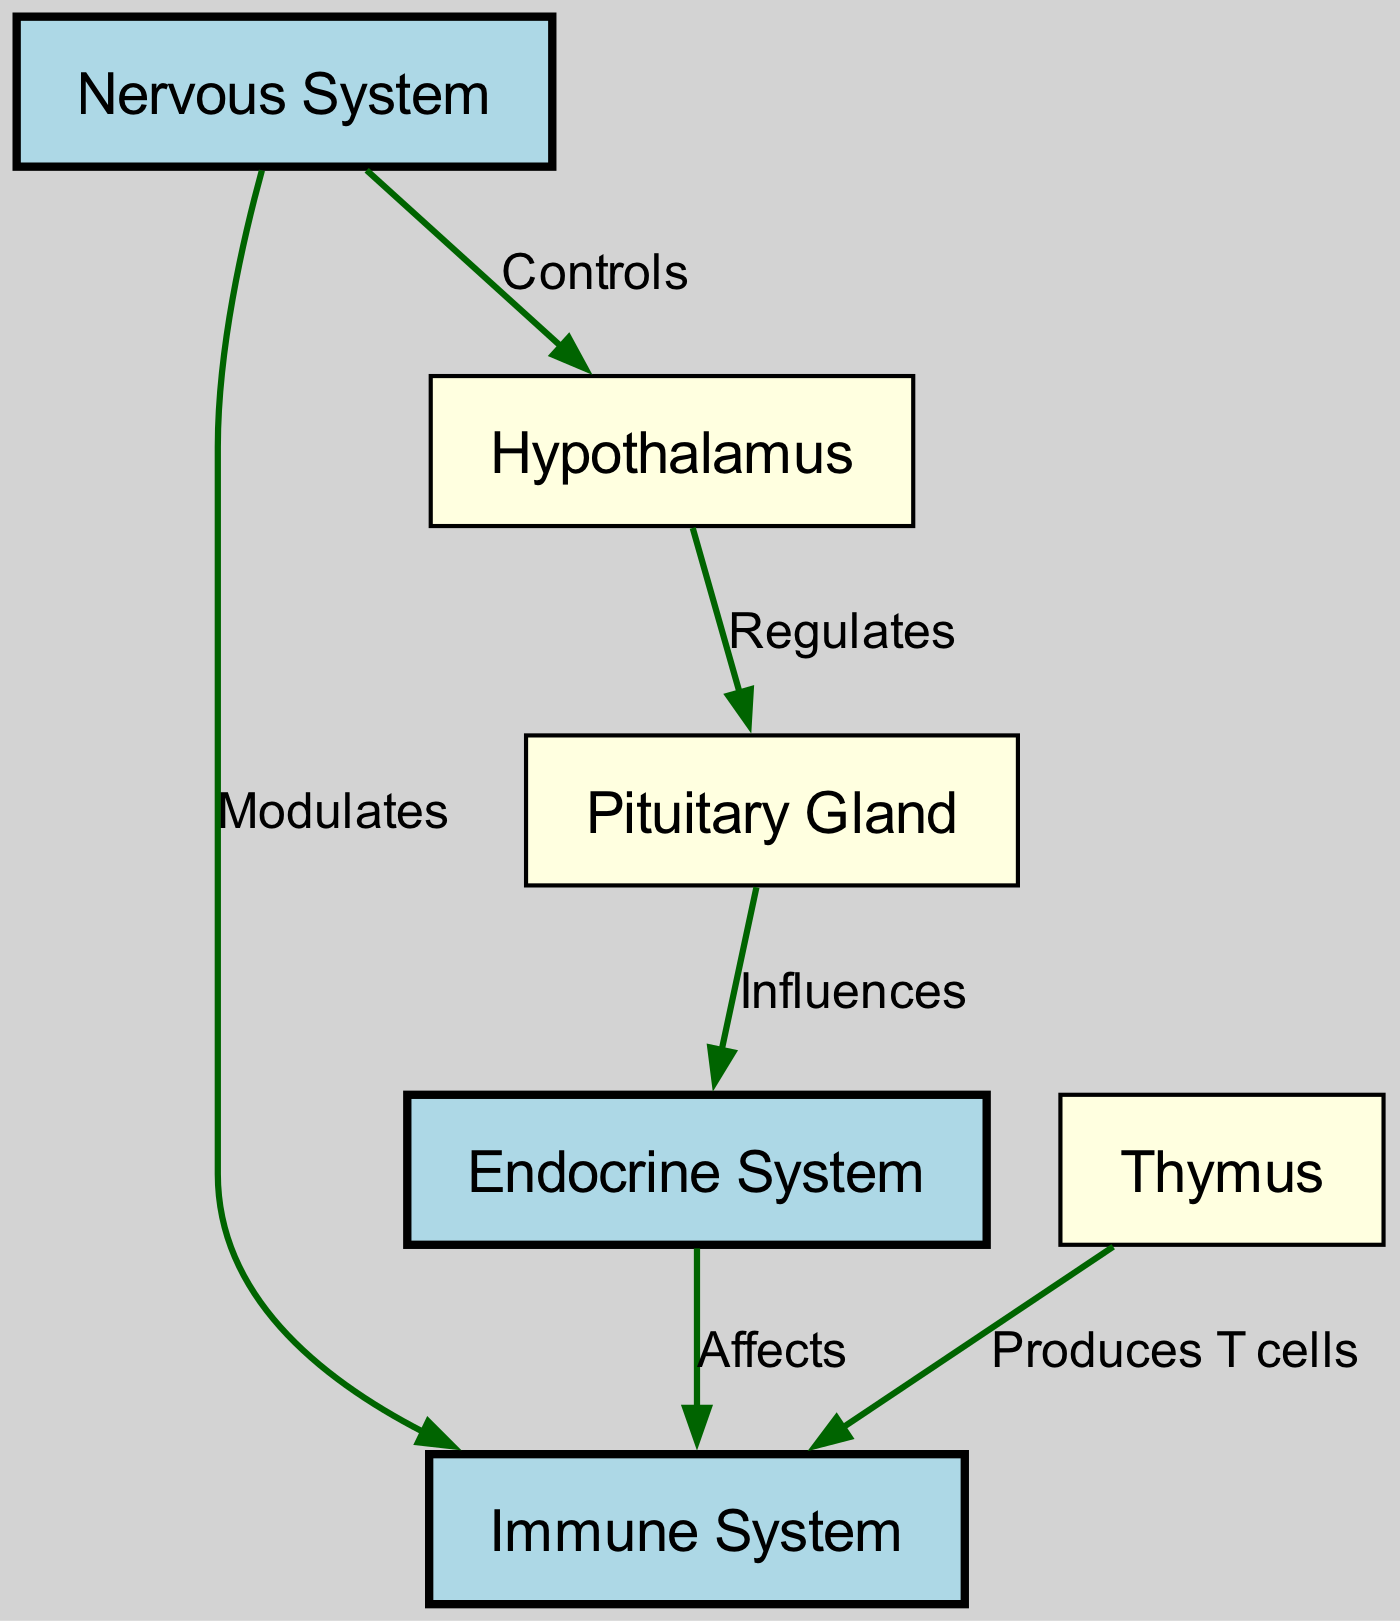What systems are represented in the diagram? The diagram includes three main systems: the Nervous System, Endocrine System, and Immune System. This can be identified by looking at the labeled nodes in the diagram.
Answer: Nervous System, Endocrine System, Immune System How many nodes are there in total? By counting all the individual nodes in the diagram, we find that there are six nodes present: the three systems plus the Hypothalamus, Pituitary Gland, and Thymus.
Answer: 6 What relationship does the Hypothalamus have with the Pituitary Gland? The arrow connecting the Hypothalamus to the Pituitary Gland is labeled "Regulates," indicating that the Hypothalamus has a regulatory relationship with the Pituitary Gland.
Answer: Regulates Which system produces T cells? The diagram shows that the Thymus is linked to the Immune System with the label "Produces T cells." This signifies that the Thymus is responsible for T cell production.
Answer: Thymus What influence does the Pituitary Gland have on the Endocrine System? The connection labeled "Influences" from the Pituitary Gland to the Endocrine System indicates that the Pituitary Gland has an influential role over the functioning of the Endocrine System.
Answer: Influences How does the Nervous System interact with the Immune System? The diagram illustrates that the Nervous System "Modulates" the Immune System, indicating a dynamic interaction where the Nervous System adjusts or influences immune functions.
Answer: Modulates What is the connection between the Endocrine System and the Immune System? The link labeled "Affects" between the Endocrine System and the Immune System shows that the Endocrine System has an effect on the Immune System, indicating their interconnectedness.
Answer: Affects Which node directly influences the Endocrine System? The Pituitary Gland is shown to influence the Endocrine System, making it the node that exerts this influence.
Answer: Pituitary Gland What is the role of the Thymus in the immune system? The diagram specifies that the Thymus plays a role in producing T cells for the immune system, thereby highlighting its essential function.
Answer: Produces T cells 